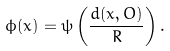<formula> <loc_0><loc_0><loc_500><loc_500>\phi ( x ) = \psi \left ( \frac { d ( x , O ) } { R } \right ) .</formula> 